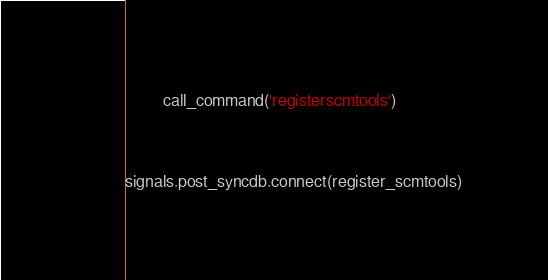Convert code to text. <code><loc_0><loc_0><loc_500><loc_500><_Python_>        call_command('registerscmtools')


signals.post_syncdb.connect(register_scmtools)
</code> 